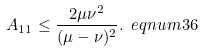<formula> <loc_0><loc_0><loc_500><loc_500>A _ { 1 1 } \leq \frac { 2 \mu \nu ^ { 2 } } { ( \mu - \nu ) ^ { 2 } } . \ e q n u m { 3 6 }</formula> 